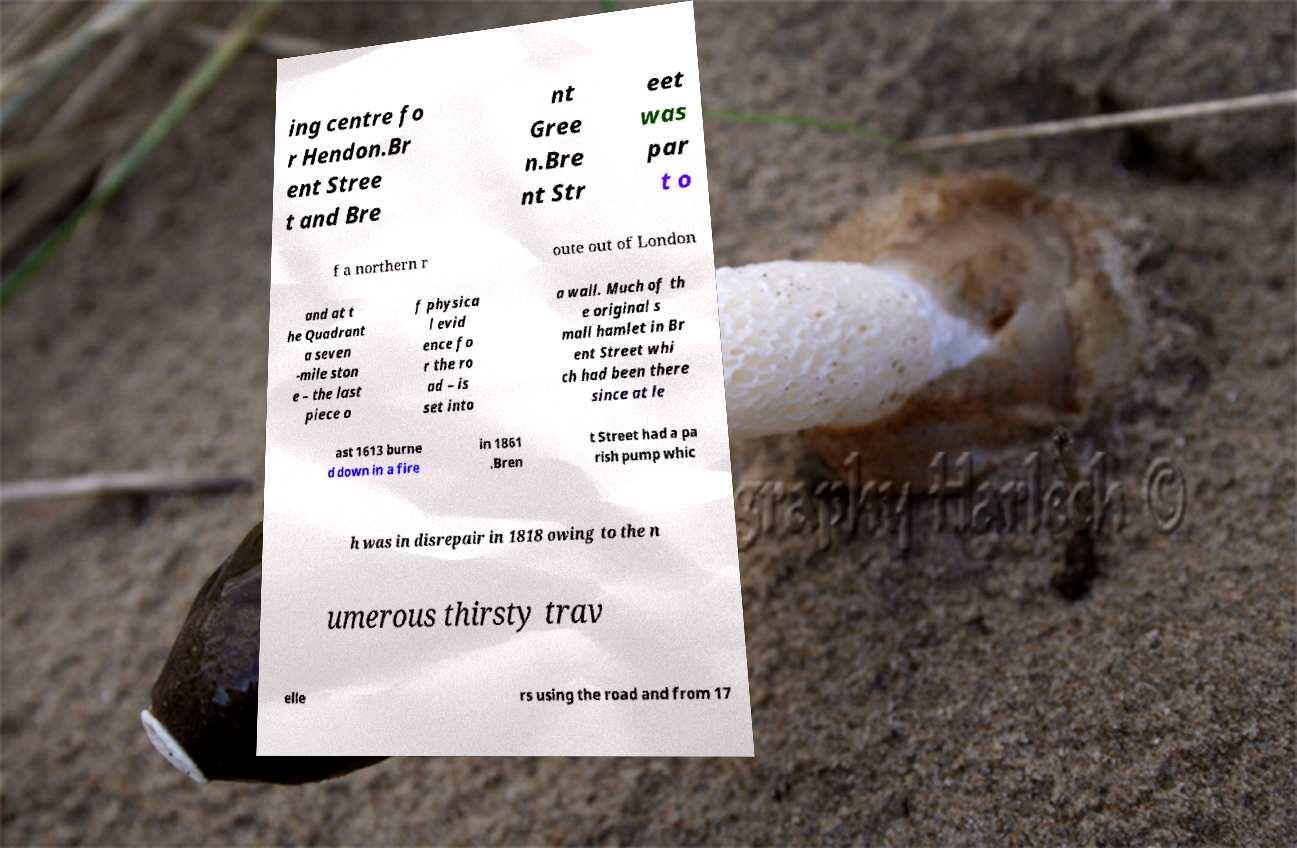Can you read and provide the text displayed in the image?This photo seems to have some interesting text. Can you extract and type it out for me? ing centre fo r Hendon.Br ent Stree t and Bre nt Gree n.Bre nt Str eet was par t o f a northern r oute out of London and at t he Quadrant a seven -mile ston e – the last piece o f physica l evid ence fo r the ro ad – is set into a wall. Much of th e original s mall hamlet in Br ent Street whi ch had been there since at le ast 1613 burne d down in a fire in 1861 .Bren t Street had a pa rish pump whic h was in disrepair in 1818 owing to the n umerous thirsty trav elle rs using the road and from 17 